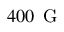<formula> <loc_0><loc_0><loc_500><loc_500>4 0 0 { \, G }</formula> 